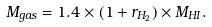Convert formula to latex. <formula><loc_0><loc_0><loc_500><loc_500>M _ { g a s } = 1 . 4 \times ( 1 + r _ { H _ { 2 } } ) \times M _ { H I } .</formula> 